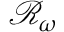Convert formula to latex. <formula><loc_0><loc_0><loc_500><loc_500>\mathcal { R } _ { \omega }</formula> 